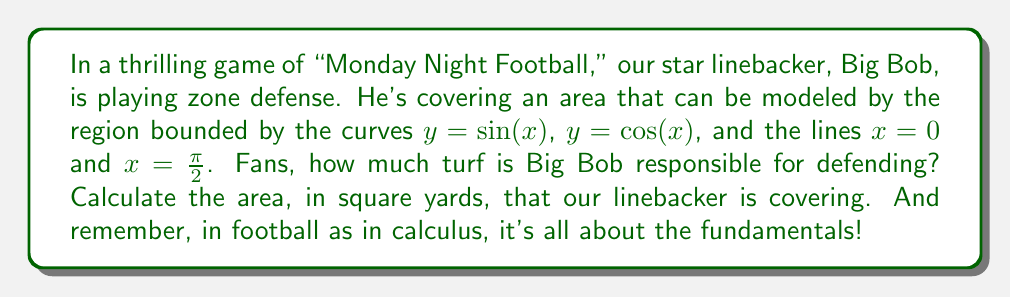Provide a solution to this math problem. To tackle this problem, we'll need to use double integration. Here's our game plan:

1) The region we're interested in is bounded by $y = \sin(x)$ above, $y = \cos(x)$ below, and $x = 0$ and $x = \frac{\pi}{2}$ on the sides.

2) We'll set up our double integral with $x$ going from 0 to $\frac{\pi}{2}$, and $y$ going from $\cos(x)$ to $\sin(x)$:

   $$A = \int_0^{\frac{\pi}{2}} \int_{\cos(x)}^{\sin(x)} dy \, dx$$

3) Let's integrate with respect to $y$ first:

   $$A = \int_0^{\frac{\pi}{2}} [y]_{\cos(x)}^{\sin(x)} dx = \int_0^{\frac{\pi}{2}} [\sin(x) - \cos(x)] dx$$

4) Now we integrate with respect to $x$:

   $$A = [-\cos(x) - \sin(x)]_0^{\frac{\pi}{2}}$$

5) Evaluate the integral:

   $$A = [-\cos(\frac{\pi}{2}) - \sin(\frac{\pi}{2})] - [-\cos(0) - \sin(0)]$$
   $$A = [0 - 1] - [-1 - 0] = -1 + 1 = 0$$

6) The area is 0 square units (or square yards in this context).

This result might seem surprising at first, but if we look at the graph of these functions, we can see that the areas above and below the $x$-axis cancel each other out perfectly.

[asy]
import graph;
size(200);
real f(real x) {return sin(x);}
real g(real x) {return cos(x);}
draw(graph(f,0,pi/2),blue);
draw(graph(g,0,pi/2),red);
draw((0,0)--(pi/2,0),black);
draw((0,0)--(0,1),black);
draw((pi/2,0)--(pi/2,1),black);
label("y=sin(x)",(.8,0.7),NE,blue);
label("y=cos(x)",(.8,0.7),SE,red);
label("x=0",(0,0.5),W);
label("x=π/2",(pi/2,0.5),E);
[/asy]
Answer: The area covered by the linebacker in zone defense is 0 square yards. 